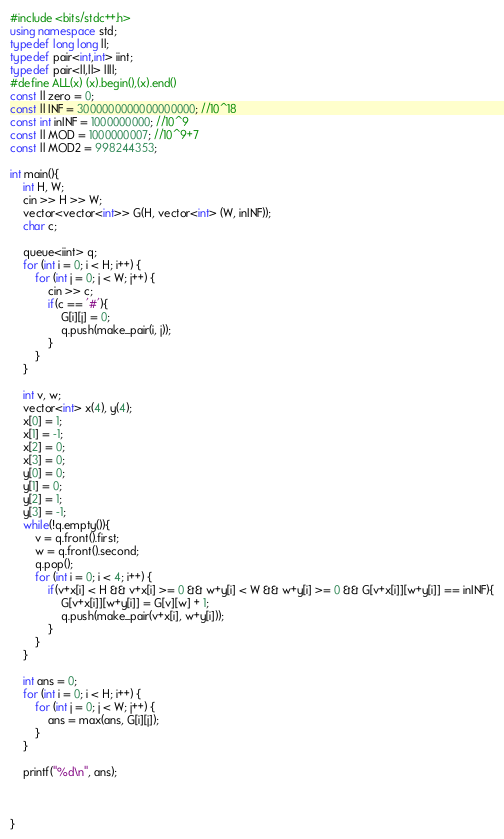Convert code to text. <code><loc_0><loc_0><loc_500><loc_500><_C++_>#include <bits/stdc++.h>
using namespace std;
typedef long long ll;
typedef pair<int,int> iint;
typedef pair<ll,ll> llll;
#define ALL(x) (x).begin(),(x).end()
const ll zero = 0;
const ll INF = 3000000000000000000; //10^18
const int inINF = 1000000000; //10^9
const ll MOD = 1000000007; //10^9+7
const ll MOD2 = 998244353;

int main(){
    int H, W;
    cin >> H >> W;
    vector<vector<int>> G(H, vector<int> (W, inINF));
    char c;

    queue<iint> q;
    for (int i = 0; i < H; i++) {
        for (int j = 0; j < W; j++) {
            cin >> c;
            if(c == '#'){
                G[i][j] = 0;
                q.push(make_pair(i, j));
            }
        }
    }

    int v, w;
    vector<int> x(4), y(4);
    x[0] = 1;
    x[1] = -1;
    x[2] = 0;
    x[3] = 0;
    y[0] = 0;
    y[1] = 0;
    y[2] = 1;
    y[3] = -1;
    while(!q.empty()){
        v = q.front().first;
        w = q.front().second;
        q.pop();
        for (int i = 0; i < 4; i++) {
            if(v+x[i] < H && v+x[i] >= 0 && w+y[i] < W && w+y[i] >= 0 && G[v+x[i]][w+y[i]] == inINF){
                G[v+x[i]][w+y[i]] = G[v][w] + 1;
                q.push(make_pair(v+x[i], w+y[i]));
            }
        }
    }

    int ans = 0;
    for (int i = 0; i < H; i++) {
        for (int j = 0; j < W; j++) {
            ans = max(ans, G[i][j]);
        }
    }

    printf("%d\n", ans);



}</code> 